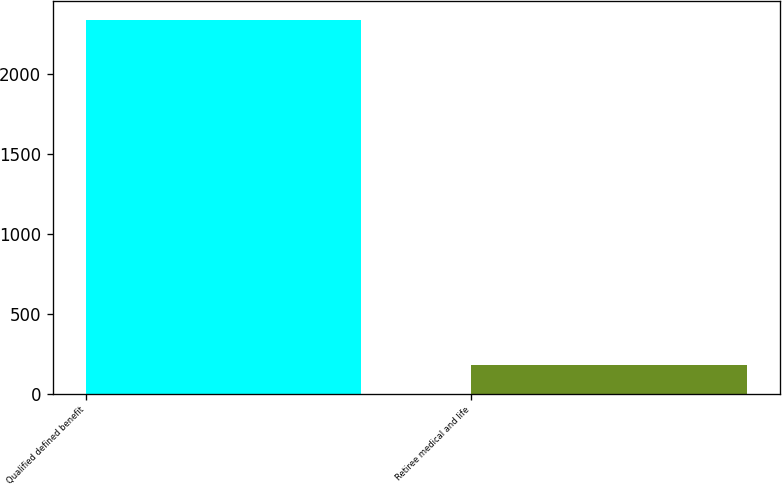Convert chart to OTSL. <chart><loc_0><loc_0><loc_500><loc_500><bar_chart><fcel>Qualified defined benefit<fcel>Retiree medical and life<nl><fcel>2340<fcel>180<nl></chart> 